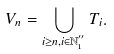<formula> <loc_0><loc_0><loc_500><loc_500>V _ { n } = \bigcup _ { i \geq n , i \in \mathbb { N } _ { 1 } ^ { ^ { \prime \prime } } } T _ { i } .</formula> 